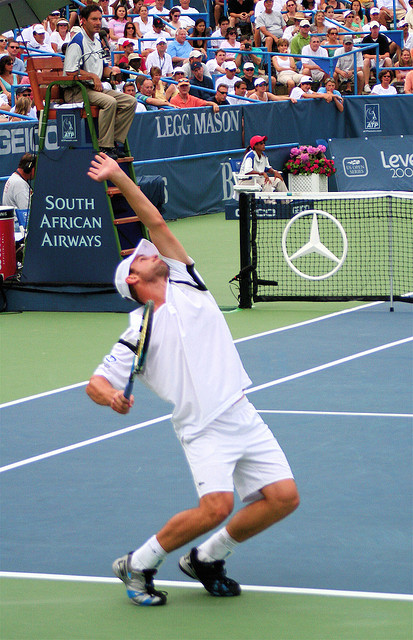Please identify all text content in this image. SOUTH AFRICAN AIRWAYS LEGG MASON GEICO 200 Lev 